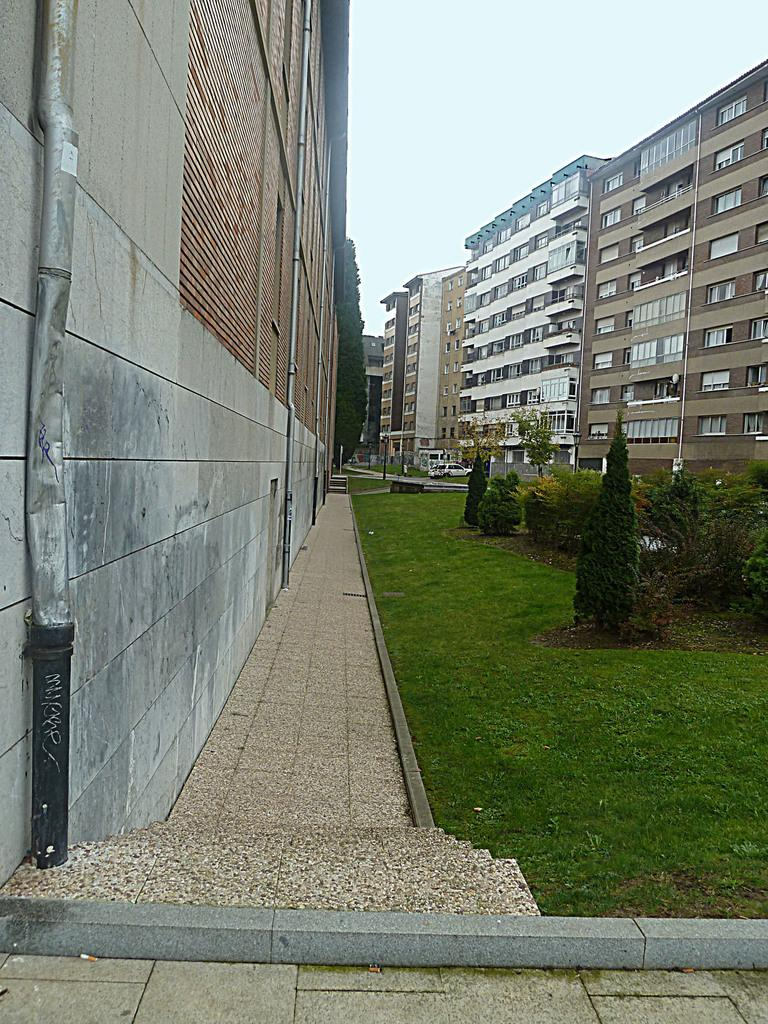What type of structures are present in the image? There are buildings with windows in the image. What type of vegetation can be seen in the image? There are trees and grass in the image. What is visible in the background of the image? The sky is visible in the background of the image. What type of bag is hanging from the tree in the image? There is no bag hanging from the tree in the image; only trees, grass, buildings, and the sky are present. 